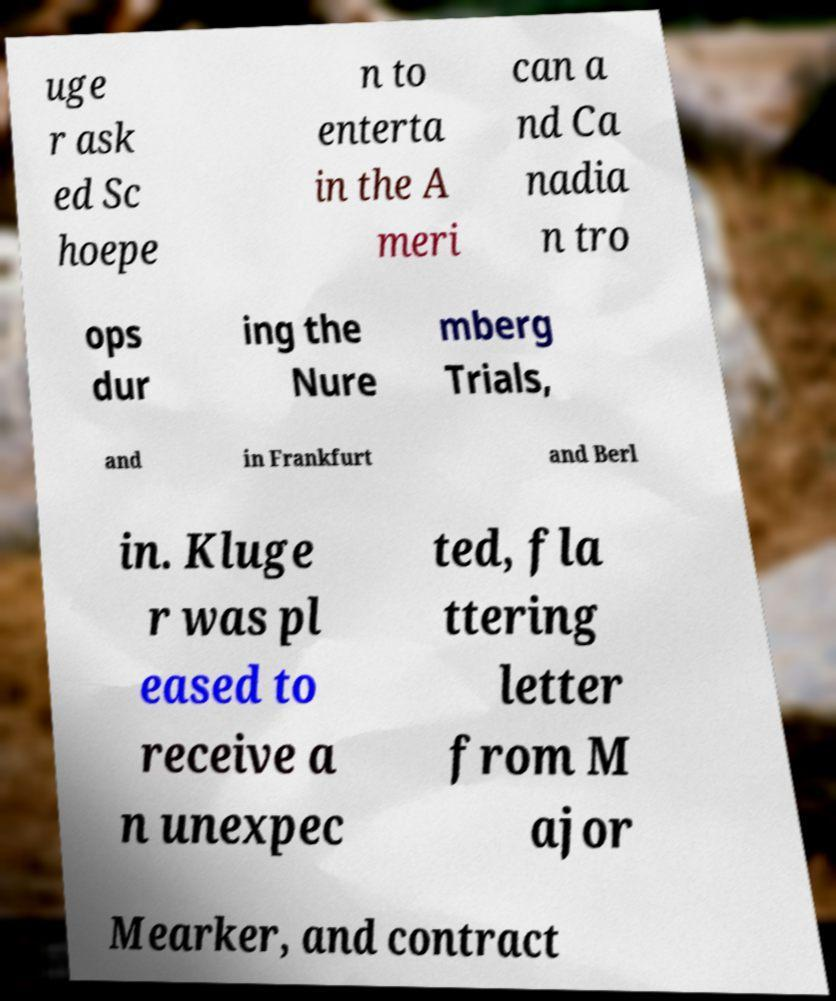Could you assist in decoding the text presented in this image and type it out clearly? uge r ask ed Sc hoepe n to enterta in the A meri can a nd Ca nadia n tro ops dur ing the Nure mberg Trials, and in Frankfurt and Berl in. Kluge r was pl eased to receive a n unexpec ted, fla ttering letter from M ajor Mearker, and contract 